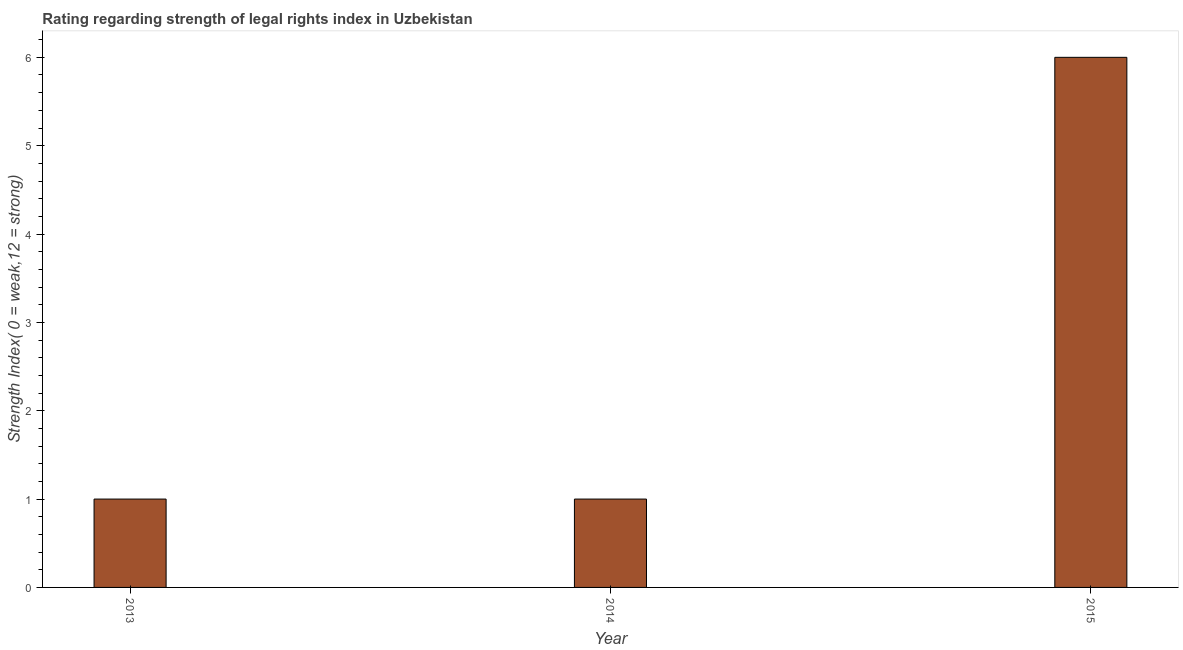Does the graph contain any zero values?
Offer a very short reply. No. What is the title of the graph?
Keep it short and to the point. Rating regarding strength of legal rights index in Uzbekistan. What is the label or title of the Y-axis?
Keep it short and to the point. Strength Index( 0 = weak,12 = strong). What is the strength of legal rights index in 2014?
Your response must be concise. 1. In which year was the strength of legal rights index maximum?
Ensure brevity in your answer.  2015. In which year was the strength of legal rights index minimum?
Provide a succinct answer. 2013. What is the average strength of legal rights index per year?
Your answer should be compact. 2. Do a majority of the years between 2015 and 2013 (inclusive) have strength of legal rights index greater than 0.6 ?
Provide a short and direct response. Yes. What is the ratio of the strength of legal rights index in 2013 to that in 2015?
Offer a terse response. 0.17. What is the difference between the highest and the second highest strength of legal rights index?
Offer a terse response. 5. Is the sum of the strength of legal rights index in 2013 and 2015 greater than the maximum strength of legal rights index across all years?
Your answer should be very brief. Yes. What is the difference between the highest and the lowest strength of legal rights index?
Offer a very short reply. 5. In how many years, is the strength of legal rights index greater than the average strength of legal rights index taken over all years?
Give a very brief answer. 1. What is the difference between two consecutive major ticks on the Y-axis?
Provide a short and direct response. 1. Are the values on the major ticks of Y-axis written in scientific E-notation?
Offer a very short reply. No. What is the difference between the Strength Index( 0 = weak,12 = strong) in 2013 and 2014?
Ensure brevity in your answer.  0. What is the difference between the Strength Index( 0 = weak,12 = strong) in 2013 and 2015?
Make the answer very short. -5. What is the ratio of the Strength Index( 0 = weak,12 = strong) in 2013 to that in 2015?
Provide a short and direct response. 0.17. What is the ratio of the Strength Index( 0 = weak,12 = strong) in 2014 to that in 2015?
Ensure brevity in your answer.  0.17. 